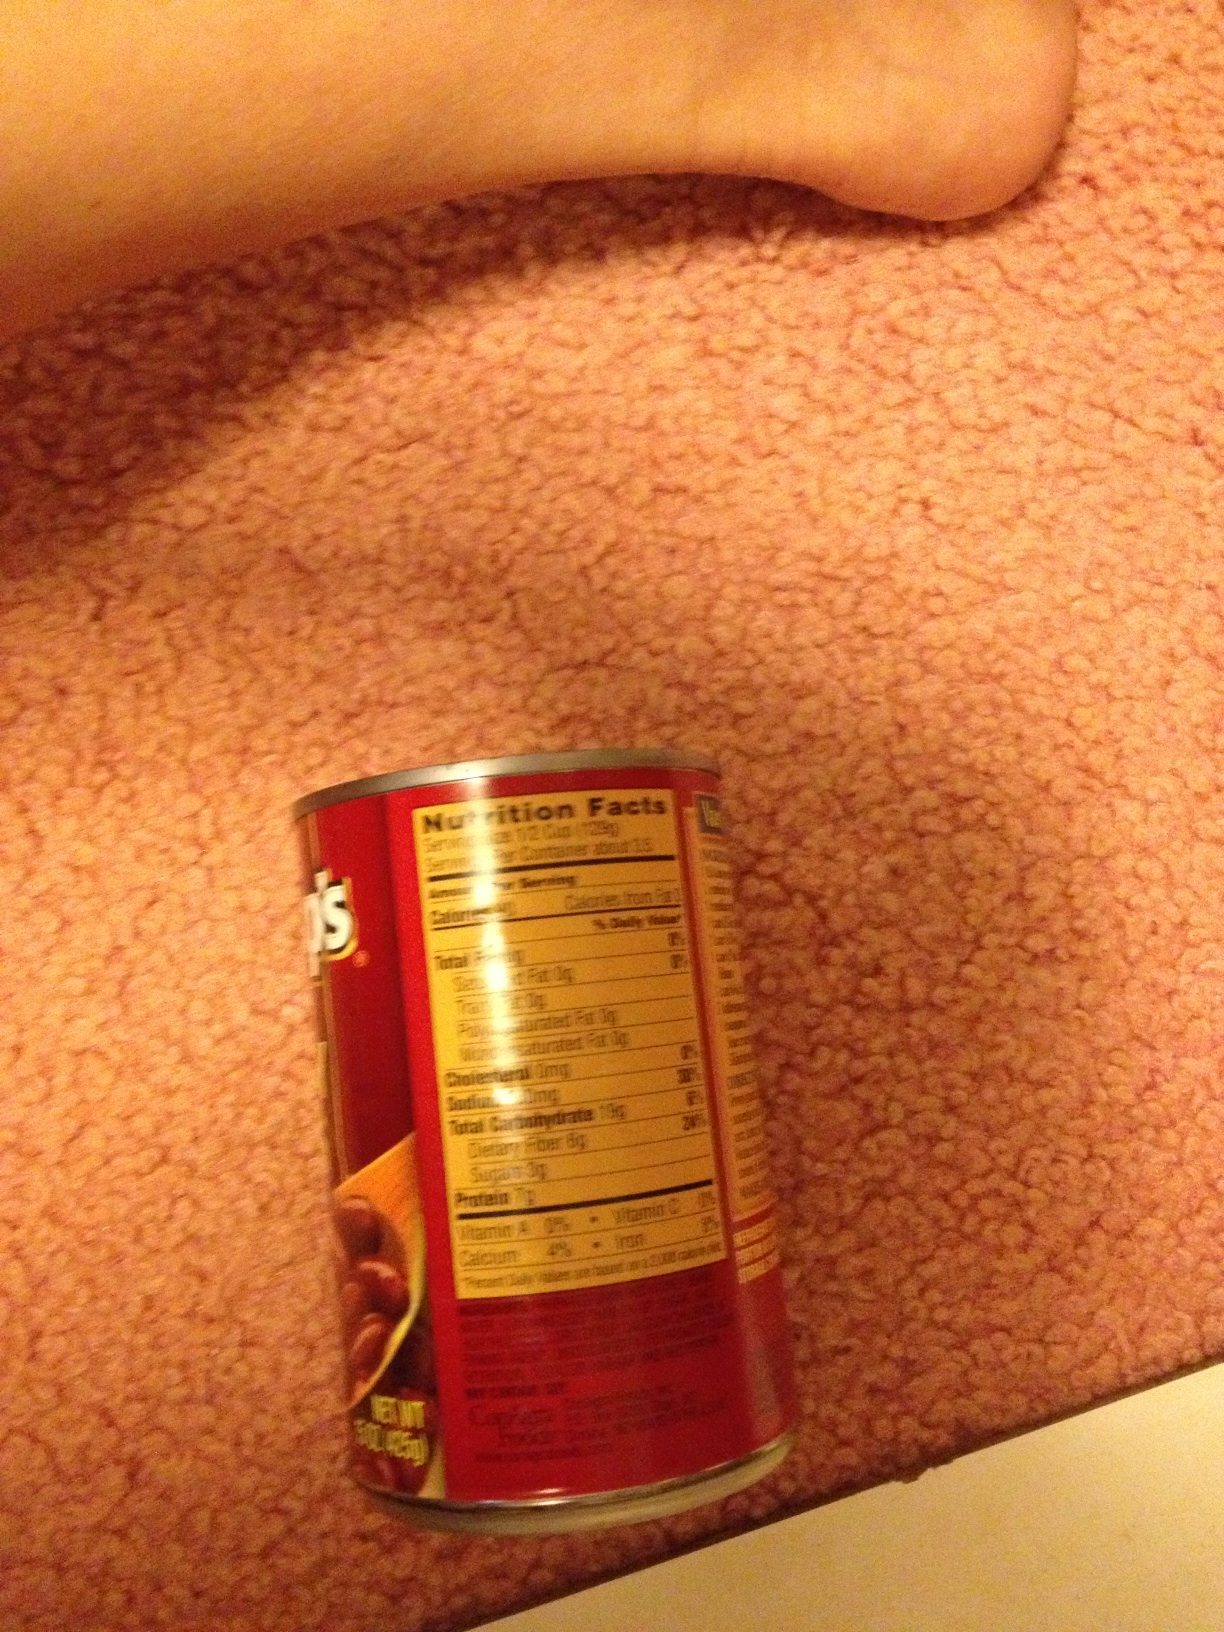If this can of beans could talk, what would it say? Hello! I'm a can of delicious beans waiting to be opened and enjoyed. I'm rich in protein and perfect for adding to your meal. Don't forget to check my nutritional information to stay informed about what you're eating! What kind of meals can you make with these beans? You can make a variety of meals with these beans! Consider making a classic bean stew, a hearty bean chili, or even a refreshing bean salad. Beans are versatile and can be a staple in many recipes. Tell me a long and detailed story about a day in the life of this can of beans. Once upon a time, in a bustling factory, this can of beans was carefully filled and sealed, destined for a culinary adventure. The can traveled from the factory on a lengthy journey, passing through various hands and places. Finally, it arrived at a grocery store, where it patiently waited on the shelf. One day, a kind person picked it up, intrigued by its nutritional benefits and the potential delicious meals it could help create. The can of beans found itself in a cozy home, nestled in the kitchen cupboard. During meal preparations, it was chosen to be part of a hearty chili recipe, contributing its rich flavor and nutrition. It felt proud and content, knowing it was providing sustenance and joy to the people who consumed it. 